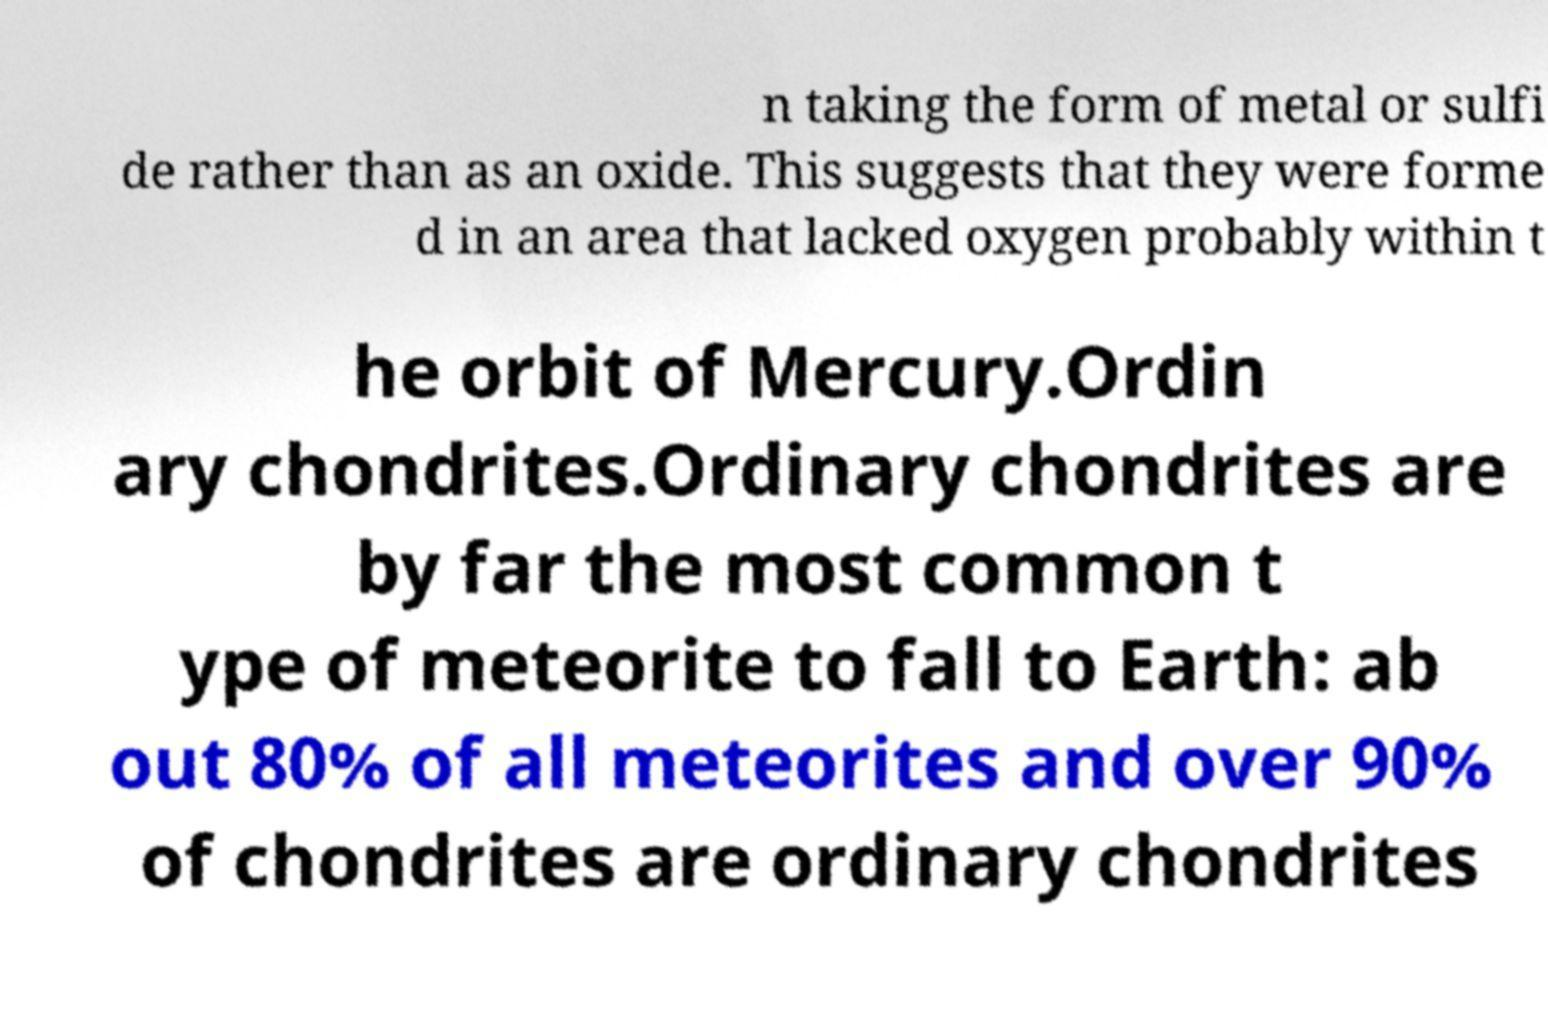Can you read and provide the text displayed in the image?This photo seems to have some interesting text. Can you extract and type it out for me? n taking the form of metal or sulfi de rather than as an oxide. This suggests that they were forme d in an area that lacked oxygen probably within t he orbit of Mercury.Ordin ary chondrites.Ordinary chondrites are by far the most common t ype of meteorite to fall to Earth: ab out 80% of all meteorites and over 90% of chondrites are ordinary chondrites 